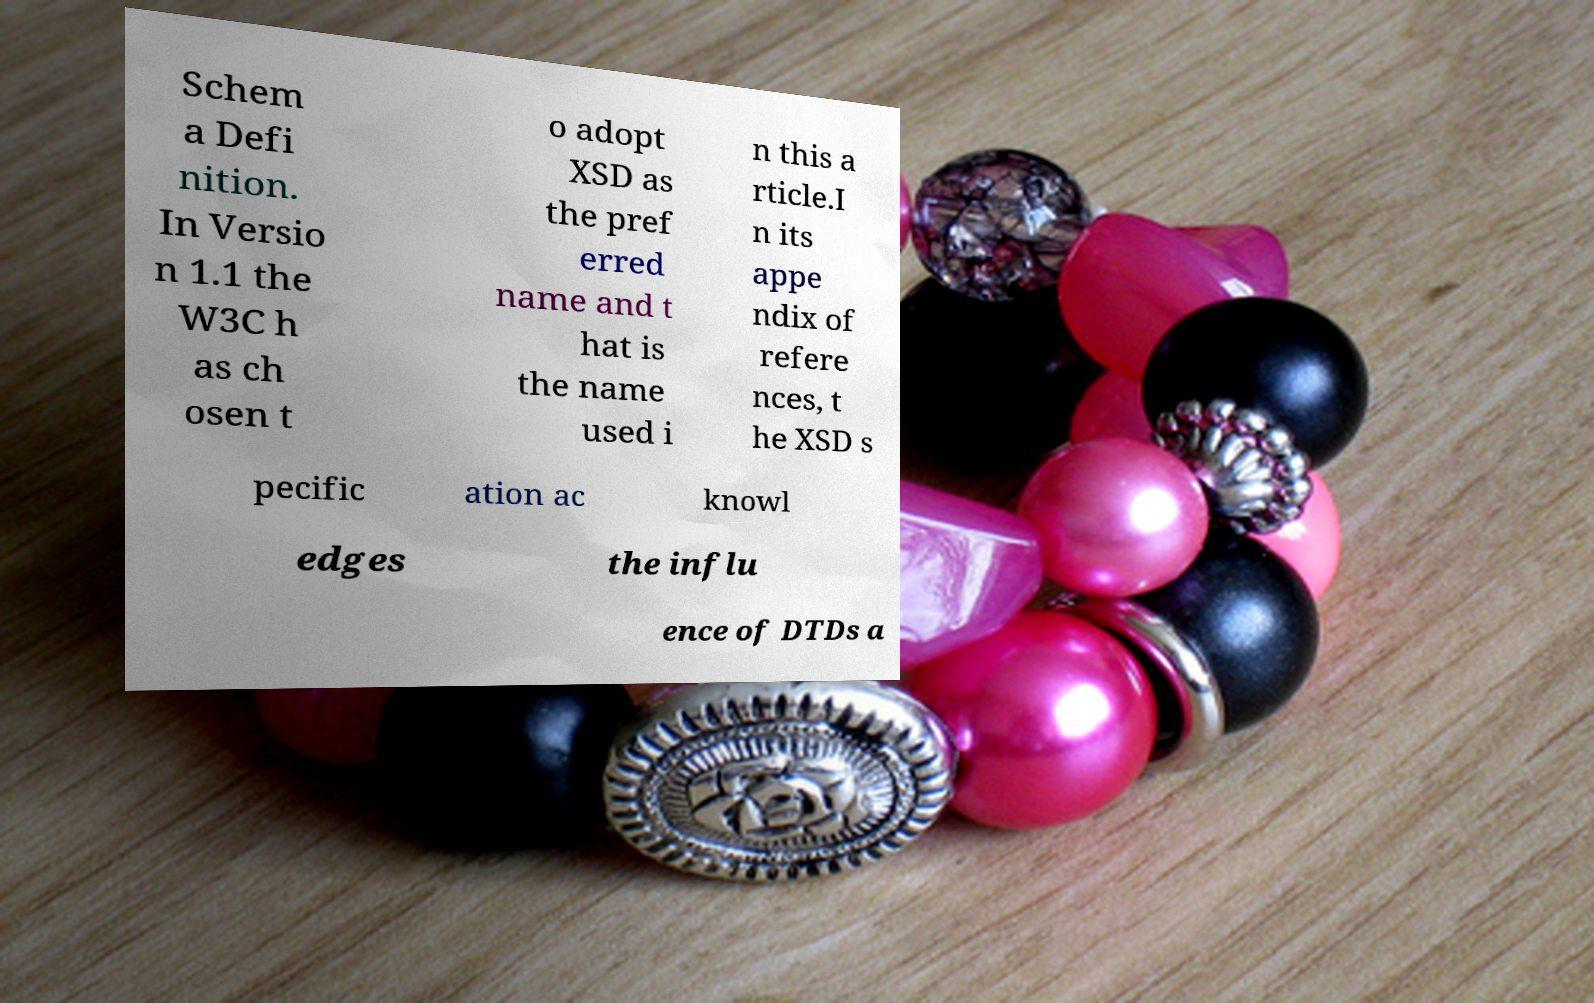Could you extract and type out the text from this image? Schem a Defi nition. In Versio n 1.1 the W3C h as ch osen t o adopt XSD as the pref erred name and t hat is the name used i n this a rticle.I n its appe ndix of refere nces, t he XSD s pecific ation ac knowl edges the influ ence of DTDs a 